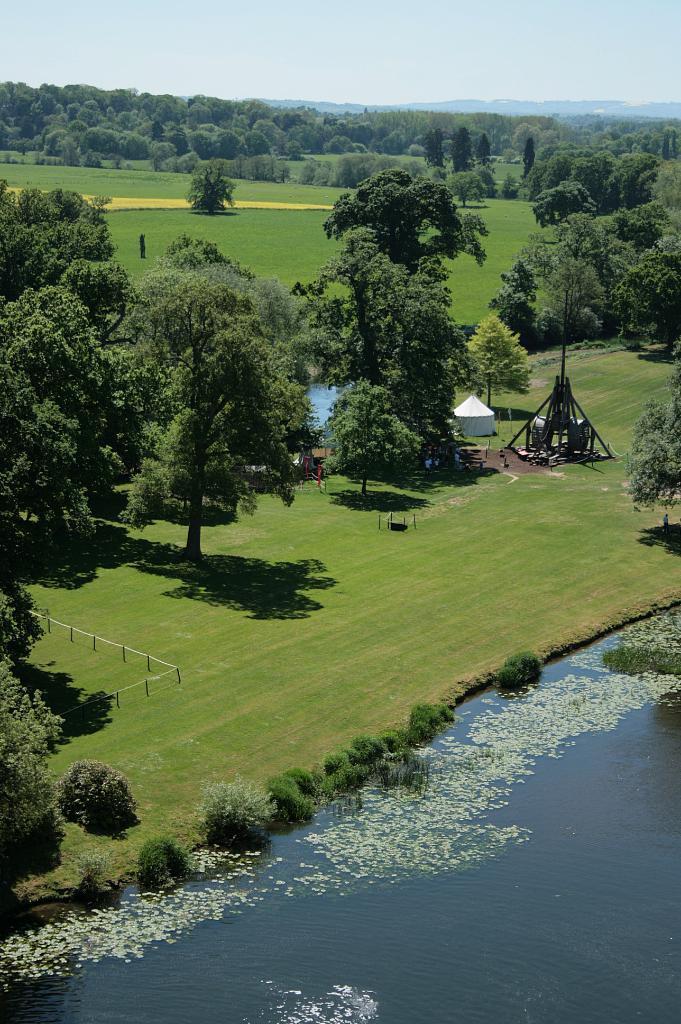Please provide a concise description of this image. At the bottom of the image there is water. On the water there is something and also there is grass in the water. Behind the water on the ground there is grass. And also there are bushes, fencing, poles and huts. And in the image there are many trees. At the top of the image there is sky. 